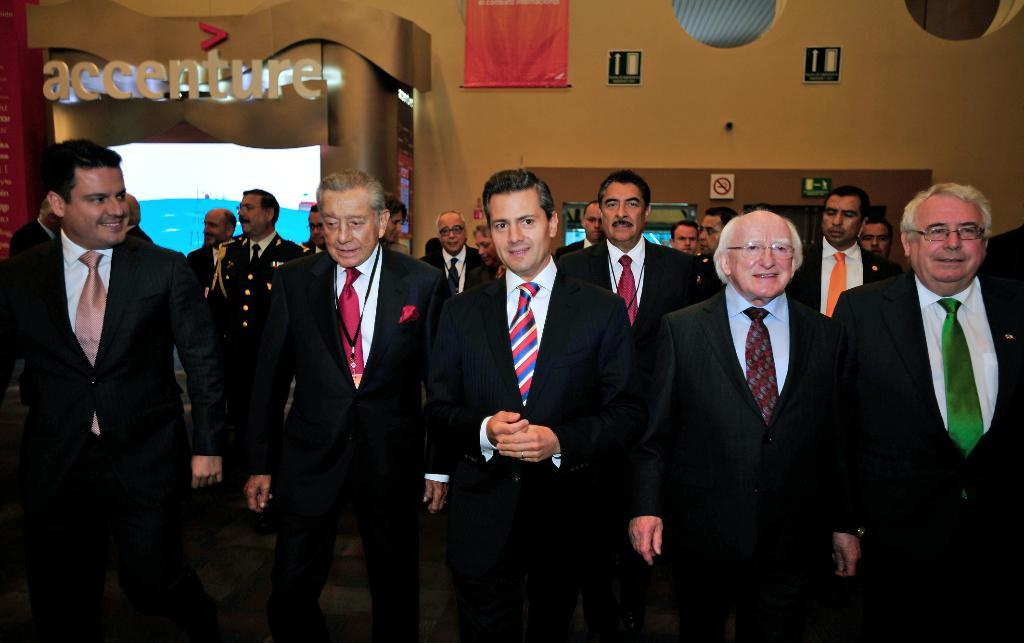How many people are in the image? There is a group of people in the image, but the exact number is not specified. What are the people doing in the image? The people are standing on the floor. What can be seen in the background of the image? There is a wall in the background of the image. What is attached to the wall in the image? There are objects attached to the wall, but their nature is not specified. What type of engine can be heard running in the background of the image? There is no engine or sound present in the image; it is a still image of people standing on the floor with a wall in the background. 